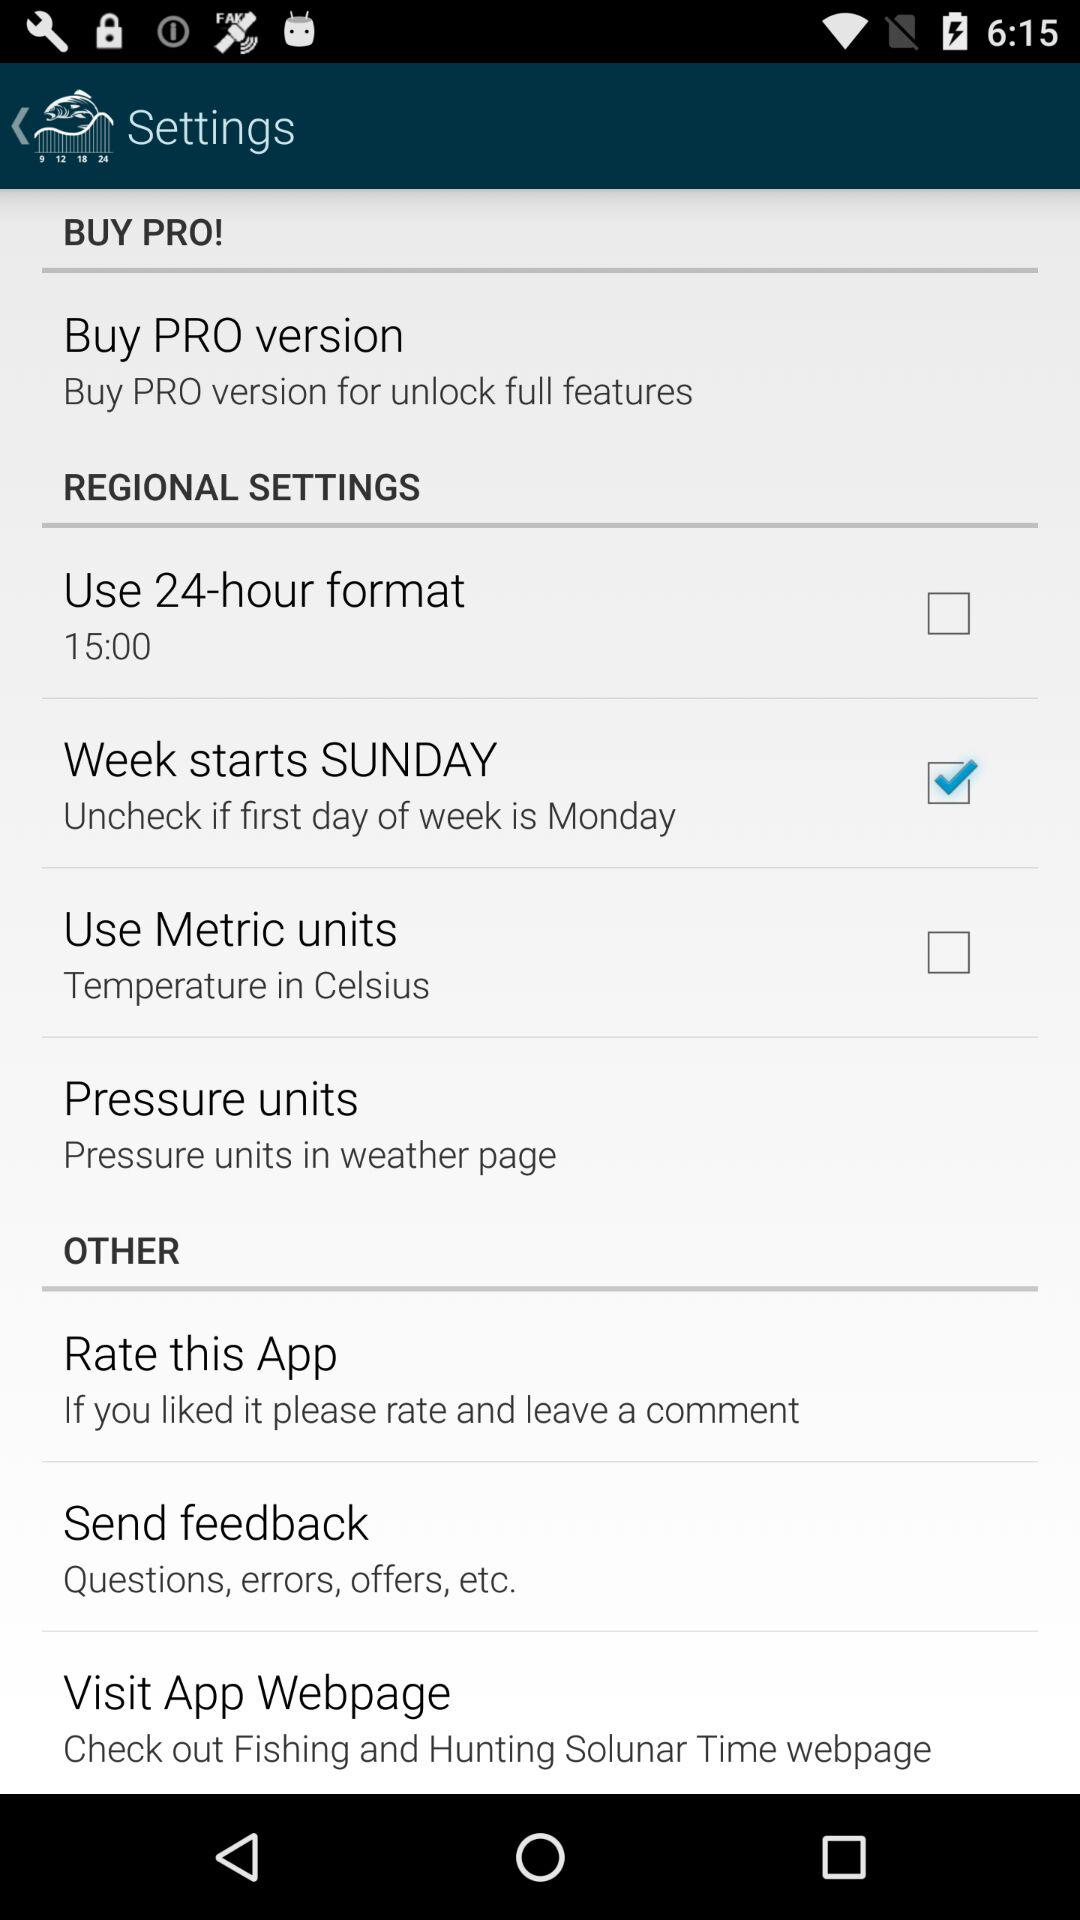How many checkbox items are there in the regional settings section?
Answer the question using a single word or phrase. 3 